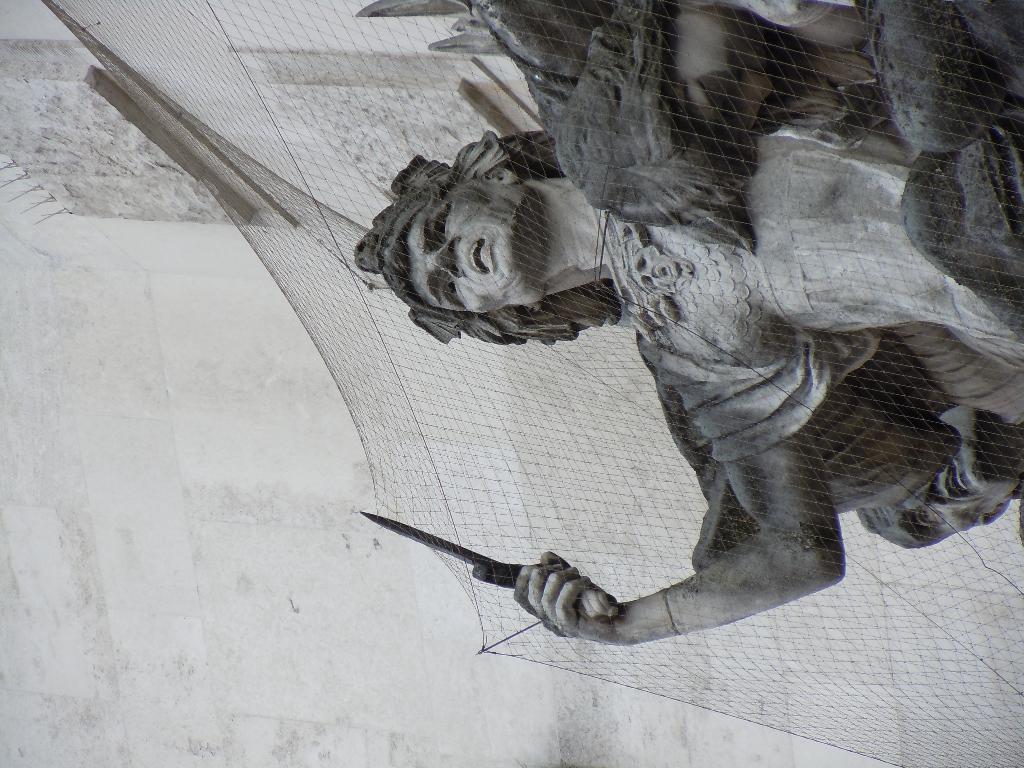Could you give a brief overview of what you see in this image? In this image I can see a sculpture on the right. There is a net over it. There is a wall at the back and this is a black and white image. 